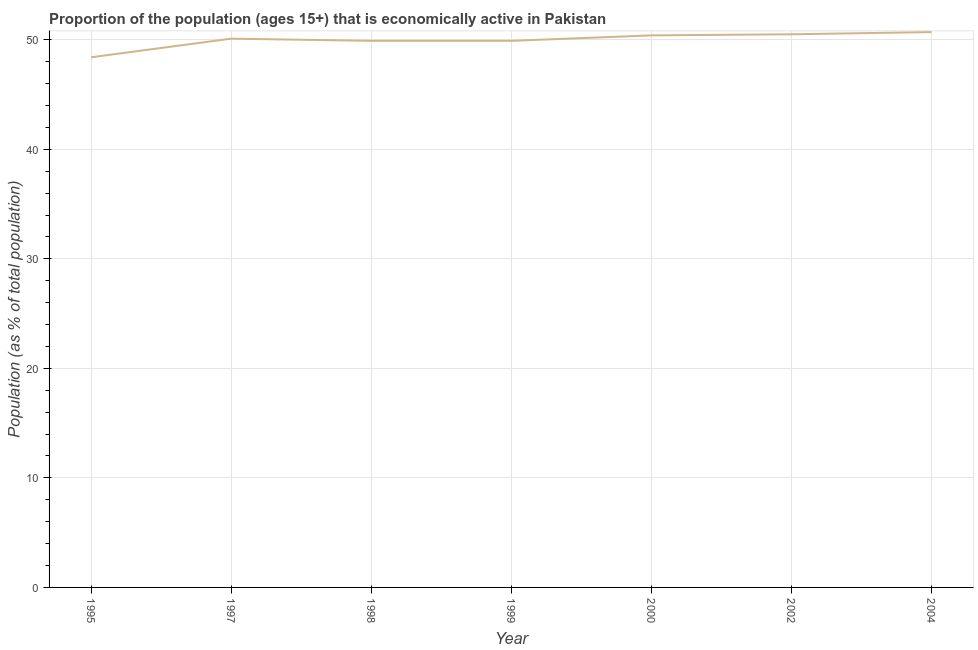What is the percentage of economically active population in 1999?
Your answer should be very brief. 49.9. Across all years, what is the maximum percentage of economically active population?
Offer a terse response. 50.7. Across all years, what is the minimum percentage of economically active population?
Your answer should be compact. 48.4. In which year was the percentage of economically active population maximum?
Your answer should be compact. 2004. In which year was the percentage of economically active population minimum?
Offer a very short reply. 1995. What is the sum of the percentage of economically active population?
Give a very brief answer. 349.9. What is the difference between the percentage of economically active population in 1997 and 1998?
Provide a short and direct response. 0.2. What is the average percentage of economically active population per year?
Offer a terse response. 49.99. What is the median percentage of economically active population?
Provide a short and direct response. 50.1. Do a majority of the years between 2000 and 2002 (inclusive) have percentage of economically active population greater than 6 %?
Ensure brevity in your answer.  Yes. What is the ratio of the percentage of economically active population in 1998 to that in 2004?
Your response must be concise. 0.98. What is the difference between the highest and the second highest percentage of economically active population?
Offer a terse response. 0.2. Is the sum of the percentage of economically active population in 1995 and 2004 greater than the maximum percentage of economically active population across all years?
Keep it short and to the point. Yes. What is the difference between the highest and the lowest percentage of economically active population?
Give a very brief answer. 2.3. How many lines are there?
Keep it short and to the point. 1. How many years are there in the graph?
Provide a succinct answer. 7. What is the difference between two consecutive major ticks on the Y-axis?
Make the answer very short. 10. What is the title of the graph?
Ensure brevity in your answer.  Proportion of the population (ages 15+) that is economically active in Pakistan. What is the label or title of the Y-axis?
Ensure brevity in your answer.  Population (as % of total population). What is the Population (as % of total population) in 1995?
Make the answer very short. 48.4. What is the Population (as % of total population) of 1997?
Provide a succinct answer. 50.1. What is the Population (as % of total population) of 1998?
Ensure brevity in your answer.  49.9. What is the Population (as % of total population) in 1999?
Provide a short and direct response. 49.9. What is the Population (as % of total population) of 2000?
Your response must be concise. 50.4. What is the Population (as % of total population) in 2002?
Your response must be concise. 50.5. What is the Population (as % of total population) of 2004?
Offer a very short reply. 50.7. What is the difference between the Population (as % of total population) in 1995 and 1999?
Keep it short and to the point. -1.5. What is the difference between the Population (as % of total population) in 1995 and 2000?
Provide a succinct answer. -2. What is the difference between the Population (as % of total population) in 1995 and 2004?
Your answer should be very brief. -2.3. What is the difference between the Population (as % of total population) in 1997 and 1998?
Give a very brief answer. 0.2. What is the difference between the Population (as % of total population) in 1997 and 1999?
Provide a short and direct response. 0.2. What is the difference between the Population (as % of total population) in 1997 and 2004?
Keep it short and to the point. -0.6. What is the difference between the Population (as % of total population) in 1998 and 2000?
Keep it short and to the point. -0.5. What is the difference between the Population (as % of total population) in 1999 and 2000?
Your response must be concise. -0.5. What is the difference between the Population (as % of total population) in 1999 and 2002?
Offer a very short reply. -0.6. What is the difference between the Population (as % of total population) in 1999 and 2004?
Your answer should be compact. -0.8. What is the difference between the Population (as % of total population) in 2000 and 2002?
Provide a succinct answer. -0.1. What is the difference between the Population (as % of total population) in 2000 and 2004?
Your answer should be very brief. -0.3. What is the difference between the Population (as % of total population) in 2002 and 2004?
Make the answer very short. -0.2. What is the ratio of the Population (as % of total population) in 1995 to that in 1998?
Provide a short and direct response. 0.97. What is the ratio of the Population (as % of total population) in 1995 to that in 2002?
Keep it short and to the point. 0.96. What is the ratio of the Population (as % of total population) in 1995 to that in 2004?
Offer a terse response. 0.95. What is the ratio of the Population (as % of total population) in 1997 to that in 2002?
Keep it short and to the point. 0.99. What is the ratio of the Population (as % of total population) in 1998 to that in 2004?
Provide a short and direct response. 0.98. What is the ratio of the Population (as % of total population) in 1999 to that in 2004?
Offer a very short reply. 0.98. What is the ratio of the Population (as % of total population) in 2000 to that in 2004?
Ensure brevity in your answer.  0.99. What is the ratio of the Population (as % of total population) in 2002 to that in 2004?
Keep it short and to the point. 1. 